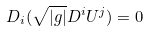<formula> <loc_0><loc_0><loc_500><loc_500>D _ { i } ( \sqrt { | g | } D ^ { i } U ^ { j } ) = 0</formula> 